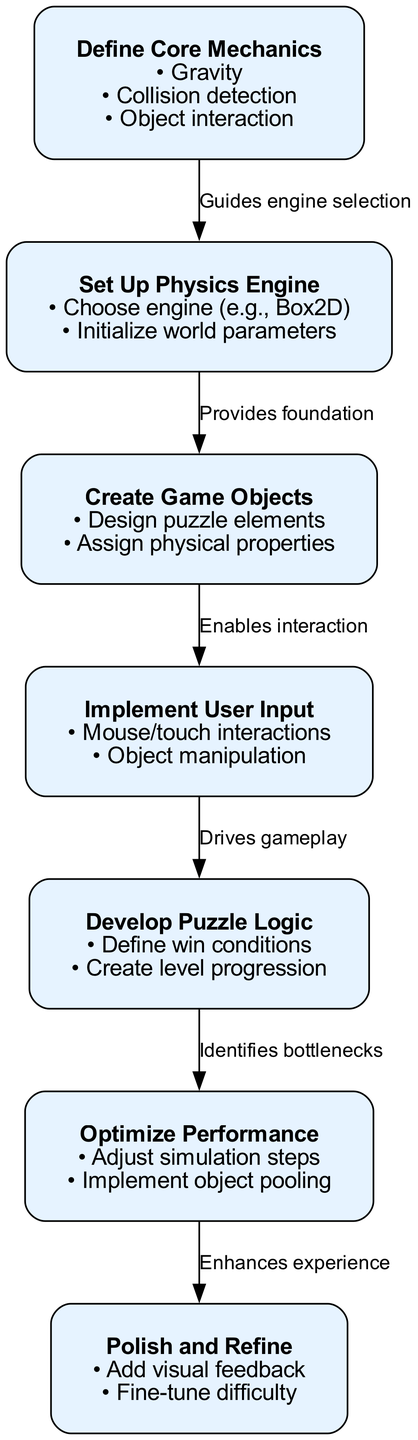What is the first step in the puzzle system implementation? The diagram lists "Define Core Mechanics" as the first step, as it appears at the top of the diagram in a sequence that guides the implementation process.
Answer: Define Core Mechanics How many steps are there in total in the diagram? By counting the individual steps listed in the diagram, there are seven steps presented in the implementation process.
Answer: 7 What connects "Create Game Objects" to "Implement User Input"? The diagram indicates that "Create Game Objects" is connected to "Implement User Input" with the label "Enables interaction," which describes the relationship between these two steps.
Answer: Enables interaction What step follows "Optimize Performance"? The diagram shows that "Polish and Refine" is the step that directly follows "Optimize Performance" in the sequence of implementation.
Answer: Polish and Refine Which step drives gameplay? According to the diagram, "Implement User Input" is labeled as the step that drives gameplay, connecting user interactions to the puzzle logic.
Answer: Implement User Input How does "Define Core Mechanics" affect "Set Up Physics Engine"? The relationship between "Define Core Mechanics" and "Set Up Physics Engine" is characterized by the label "Guides engine selection," indicating that defining the core mechanics informs the choice of the physics engine.
Answer: Guides engine selection What is the label of the edge connecting "Develop Puzzle Logic" to "Optimize Performance"? The edge connecting these two steps is labeled "Identifies bottlenecks," suggesting how developing puzzle logic leads to recognizing performance issues.
Answer: Identifies bottlenecks What is the last step in the diagram? The diagram concludes with "Polish and Refine" as the last step, indicating it is the final phase of the implementation process.
Answer: Polish and Refine How many connections are shown between the steps in the diagram? By counting the edges that connect the various steps, there are six connections shown in the implementation process.
Answer: 6 